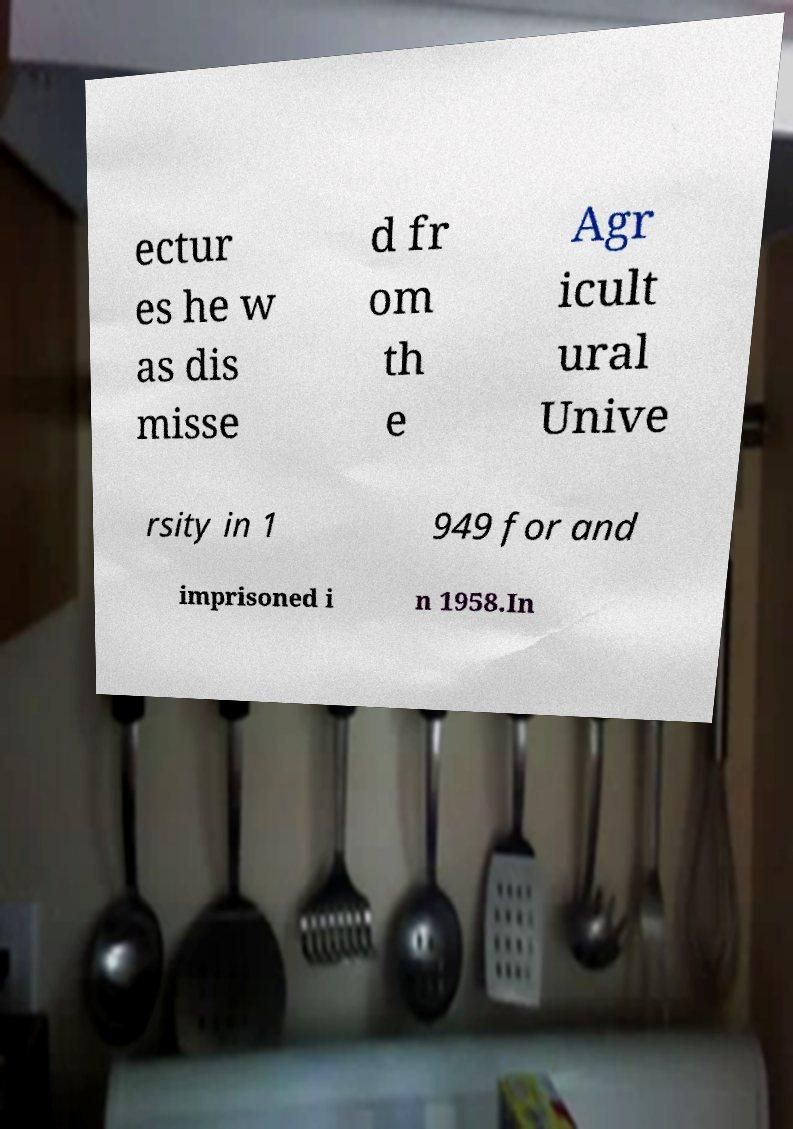What messages or text are displayed in this image? I need them in a readable, typed format. ectur es he w as dis misse d fr om th e Agr icult ural Unive rsity in 1 949 for and imprisoned i n 1958.In 